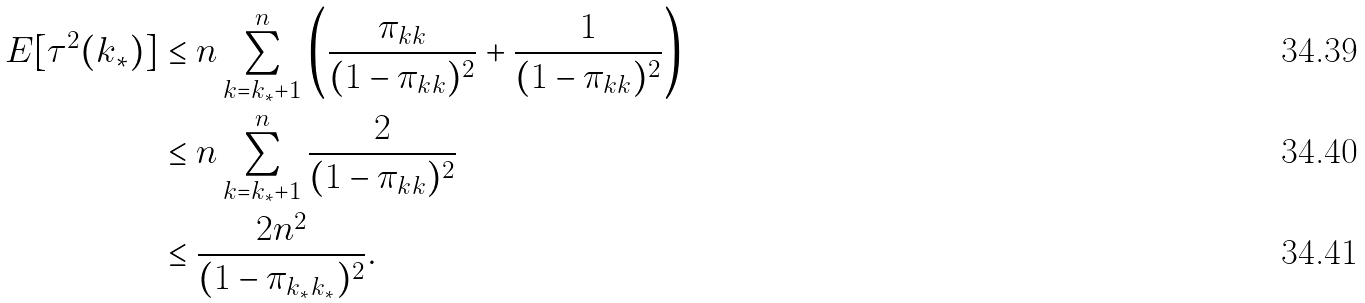<formula> <loc_0><loc_0><loc_500><loc_500>E [ \tau ^ { 2 } ( k _ { * } ) ] & \leq n \sum _ { k = k _ { * } + 1 } ^ { n } \left ( \frac { \pi _ { k k } } { ( 1 - \pi _ { k k } ) ^ { 2 } } + \frac { 1 } { ( 1 - \pi _ { k k } ) ^ { 2 } } \right ) \\ & \leq n \sum _ { k = k _ { * } + 1 } ^ { n } \frac { 2 } { ( 1 - \pi _ { k k } ) ^ { 2 } } \\ & \leq \frac { 2 n ^ { 2 } } { ( 1 - \pi _ { k _ { * } k _ { * } } ) ^ { 2 } } .</formula> 